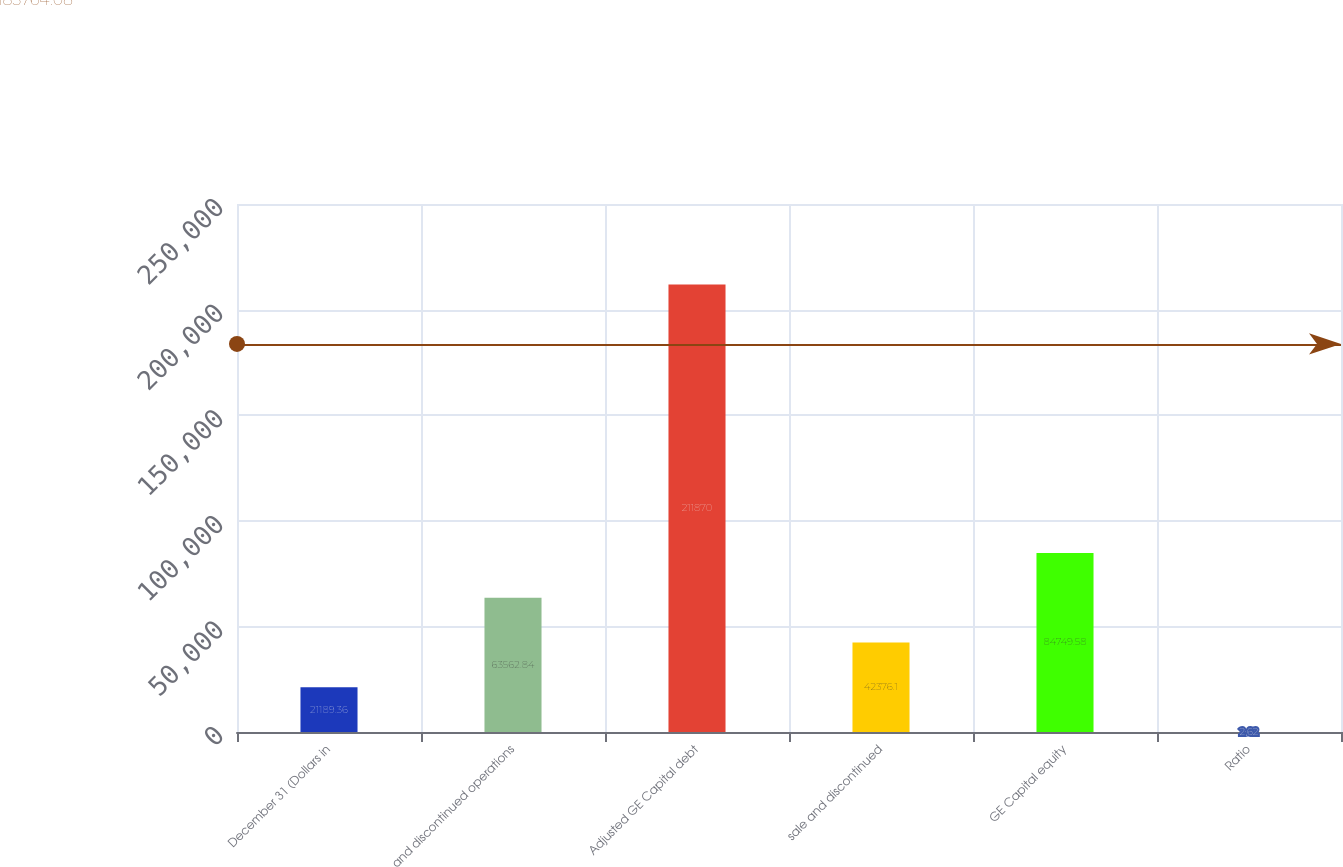<chart> <loc_0><loc_0><loc_500><loc_500><bar_chart><fcel>December 31 (Dollars in<fcel>and discontinued operations<fcel>Adjusted GE Capital debt<fcel>sale and discontinued<fcel>GE Capital equity<fcel>Ratio<nl><fcel>21189.4<fcel>63562.8<fcel>211870<fcel>42376.1<fcel>84749.6<fcel>2.62<nl></chart> 